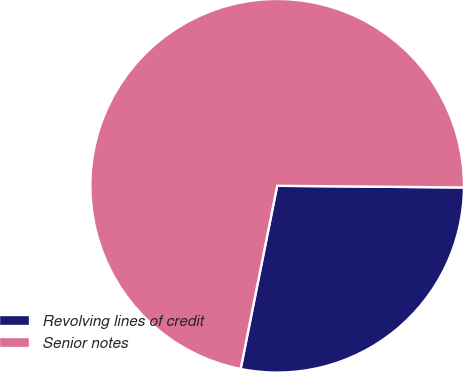<chart> <loc_0><loc_0><loc_500><loc_500><pie_chart><fcel>Revolving lines of credit<fcel>Senior notes<nl><fcel>27.99%<fcel>72.01%<nl></chart> 